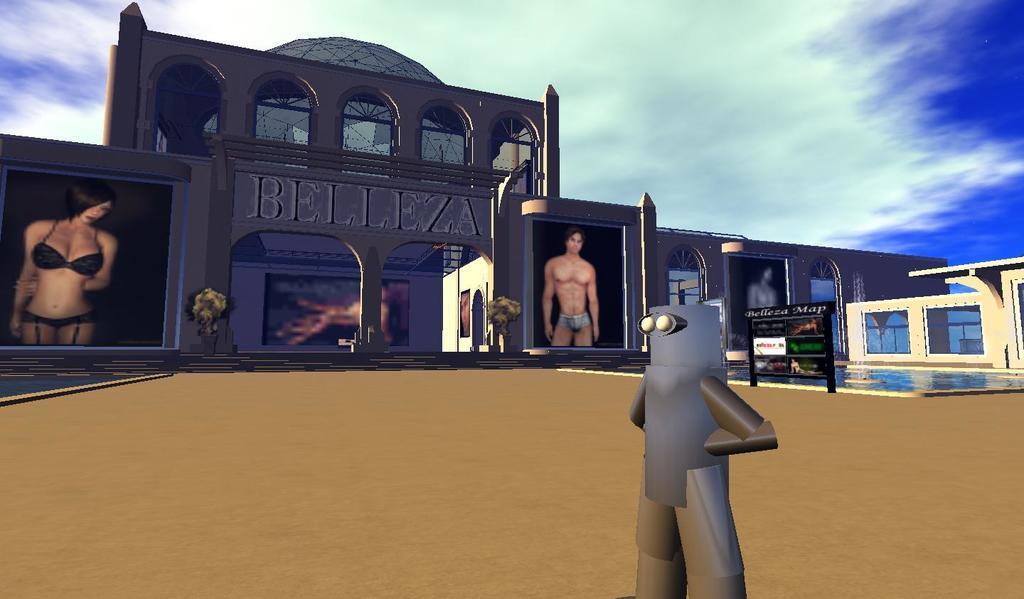How would you summarize this image in a sentence or two? By seeing this image we can say it is an edited image. On the right side of the image we can see a lady. In the middle of the image we can see a robot and a men. On the left side of the image we can see a person which is in blues and a building. 